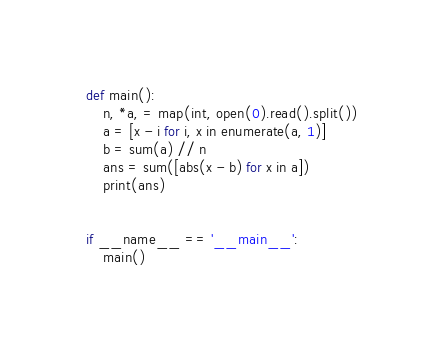<code> <loc_0><loc_0><loc_500><loc_500><_Python_>def main():
    n, *a, = map(int, open(0).read().split())
    a = [x - i for i, x in enumerate(a, 1)]
    b = sum(a) // n
    ans = sum([abs(x - b) for x in a])
    print(ans)


if __name__ == '__main__':
    main()
</code> 